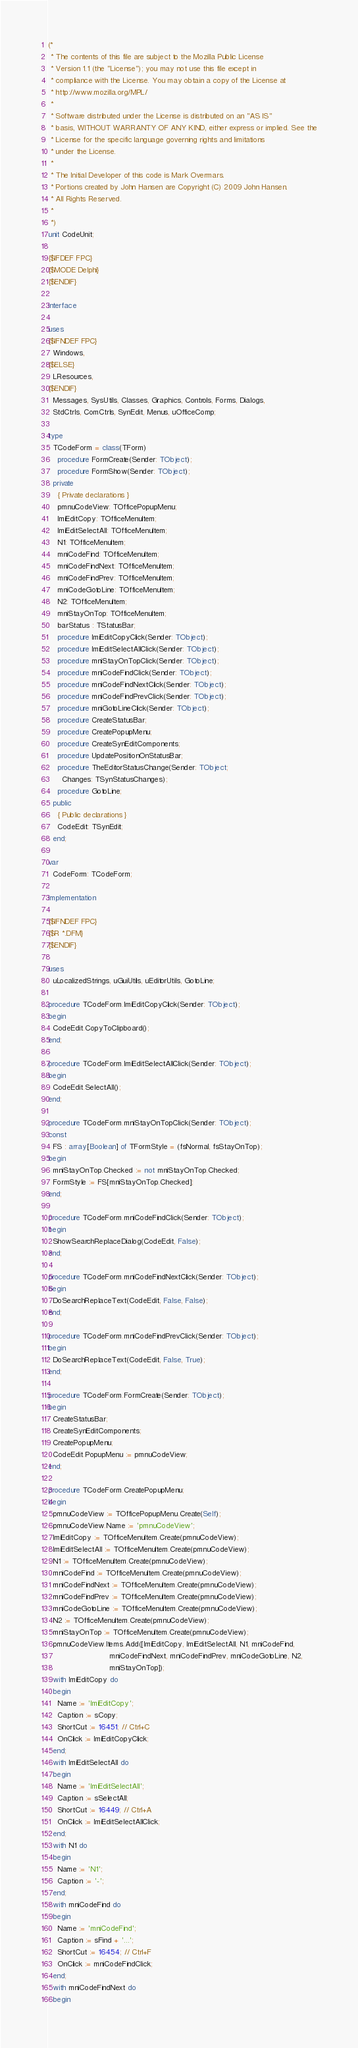<code> <loc_0><loc_0><loc_500><loc_500><_Pascal_>(*
 * The contents of this file are subject to the Mozilla Public License
 * Version 1.1 (the "License"); you may not use this file except in
 * compliance with the License. You may obtain a copy of the License at
 * http://www.mozilla.org/MPL/
 *
 * Software distributed under the License is distributed on an "AS IS"
 * basis, WITHOUT WARRANTY OF ANY KIND, either express or implied. See the
 * License for the specific language governing rights and limitations
 * under the License.
 *
 * The Initial Developer of this code is Mark Overmars.
 * Portions created by John Hansen are Copyright (C) 2009 John Hansen.
 * All Rights Reserved.
 *
 *)
unit CodeUnit;

{$IFDEF FPC}
{$MODE Delphi}
{$ENDIF}

interface

uses
{$IFNDEF FPC}
  Windows,
{$ELSE}
  LResources,
{$ENDIF}
  Messages, SysUtils, Classes, Graphics, Controls, Forms, Dialogs,
  StdCtrls, ComCtrls, SynEdit, Menus, uOfficeComp;

type
  TCodeForm = class(TForm)
    procedure FormCreate(Sender: TObject);
    procedure FormShow(Sender: TObject);
  private
    { Private declarations }
    pmnuCodeView: TOfficePopupMenu;
    lmiEditCopy: TOfficeMenuItem;
    lmiEditSelectAll: TOfficeMenuItem;
    N1: TOfficeMenuItem;
    mniCodeFind: TOfficeMenuItem;
    mniCodeFindNext: TOfficeMenuItem;
    mniCodeFindPrev: TOfficeMenuItem;
    mniCodeGotoLine: TOfficeMenuItem;
    N2: TOfficeMenuItem;
    mniStayOnTop: TOfficeMenuItem;
    barStatus : TStatusBar;
    procedure lmiEditCopyClick(Sender: TObject);
    procedure lmiEditSelectAllClick(Sender: TObject);
    procedure mniStayOnTopClick(Sender: TObject);
    procedure mniCodeFindClick(Sender: TObject);
    procedure mniCodeFindNextClick(Sender: TObject);
    procedure mniCodeFindPrevClick(Sender: TObject);
    procedure mniGotoLineClick(Sender: TObject);
    procedure CreateStatusBar;
    procedure CreatePopupMenu;
    procedure CreateSynEditComponents;
    procedure UpdatePositionOnStatusBar;
    procedure TheEditorStatusChange(Sender: TObject;
      Changes: TSynStatusChanges);
    procedure GotoLine;
  public
    { Public declarations }
    CodeEdit: TSynEdit;
  end;

var
  CodeForm: TCodeForm;

implementation

{$IFNDEF FPC}
{$R *.DFM}
{$ENDIF}

uses
  uLocalizedStrings, uGuiUtils, uEditorUtils, GotoLine;

procedure TCodeForm.lmiEditCopyClick(Sender: TObject);
begin
  CodeEdit.CopyToClipboard();
end;

procedure TCodeForm.lmiEditSelectAllClick(Sender: TObject);
begin
  CodeEdit.SelectAll();
end;

procedure TCodeForm.mniStayOnTopClick(Sender: TObject);
const
  FS : array[Boolean] of TFormStyle = (fsNormal, fsStayOnTop);
begin
  mniStayOnTop.Checked := not mniStayOnTop.Checked;
  FormStyle := FS[mniStayOnTop.Checked];
end;

procedure TCodeForm.mniCodeFindClick(Sender: TObject);
begin
  ShowSearchReplaceDialog(CodeEdit, False);
end;

procedure TCodeForm.mniCodeFindNextClick(Sender: TObject);
begin
  DoSearchReplaceText(CodeEdit, False, False);
end;

procedure TCodeForm.mniCodeFindPrevClick(Sender: TObject);
begin
  DoSearchReplaceText(CodeEdit, False, True);
end;

procedure TCodeForm.FormCreate(Sender: TObject);
begin
  CreateStatusBar;
  CreateSynEditComponents;
  CreatePopupMenu;
  CodeEdit.PopupMenu := pmnuCodeView;
end;

procedure TCodeForm.CreatePopupMenu;
begin
  pmnuCodeView := TOfficePopupMenu.Create(Self);
  pmnuCodeView.Name := 'pmnuCodeView';
  lmiEditCopy := TOfficeMenuItem.Create(pmnuCodeView);
  lmiEditSelectAll := TOfficeMenuItem.Create(pmnuCodeView);
  N1 := TOfficeMenuItem.Create(pmnuCodeView);
  mniCodeFind := TOfficeMenuItem.Create(pmnuCodeView);
  mniCodeFindNext := TOfficeMenuItem.Create(pmnuCodeView);
  mniCodeFindPrev := TOfficeMenuItem.Create(pmnuCodeView);
  mniCodeGotoLine := TOfficeMenuItem.Create(pmnuCodeView);
  N2 := TOfficeMenuItem.Create(pmnuCodeView);
  mniStayOnTop := TOfficeMenuItem.Create(pmnuCodeView);
  pmnuCodeView.Items.Add([lmiEditCopy, lmiEditSelectAll, N1, mniCodeFind,
                          mniCodeFindNext, mniCodeFindPrev, mniCodeGotoLine, N2,
                          mniStayOnTop]);
  with lmiEditCopy do
  begin
    Name := 'lmiEditCopy';
    Caption := sCopy;
    ShortCut := 16451; // Ctrl+C
    OnClick := lmiEditCopyClick;
  end;
  with lmiEditSelectAll do
  begin
    Name := 'lmiEditSelectAll';
    Caption := sSelectAll;
    ShortCut := 16449; // Ctrl+A
    OnClick := lmiEditSelectAllClick;
  end;
  with N1 do
  begin
    Name := 'N1';
    Caption := '-';
  end;
  with mniCodeFind do
  begin
    Name := 'mniCodeFind';
    Caption := sFind + '...';
    ShortCut := 16454; // Ctrl+F
    OnClick := mniCodeFindClick;
  end;
  with mniCodeFindNext do
  begin</code> 